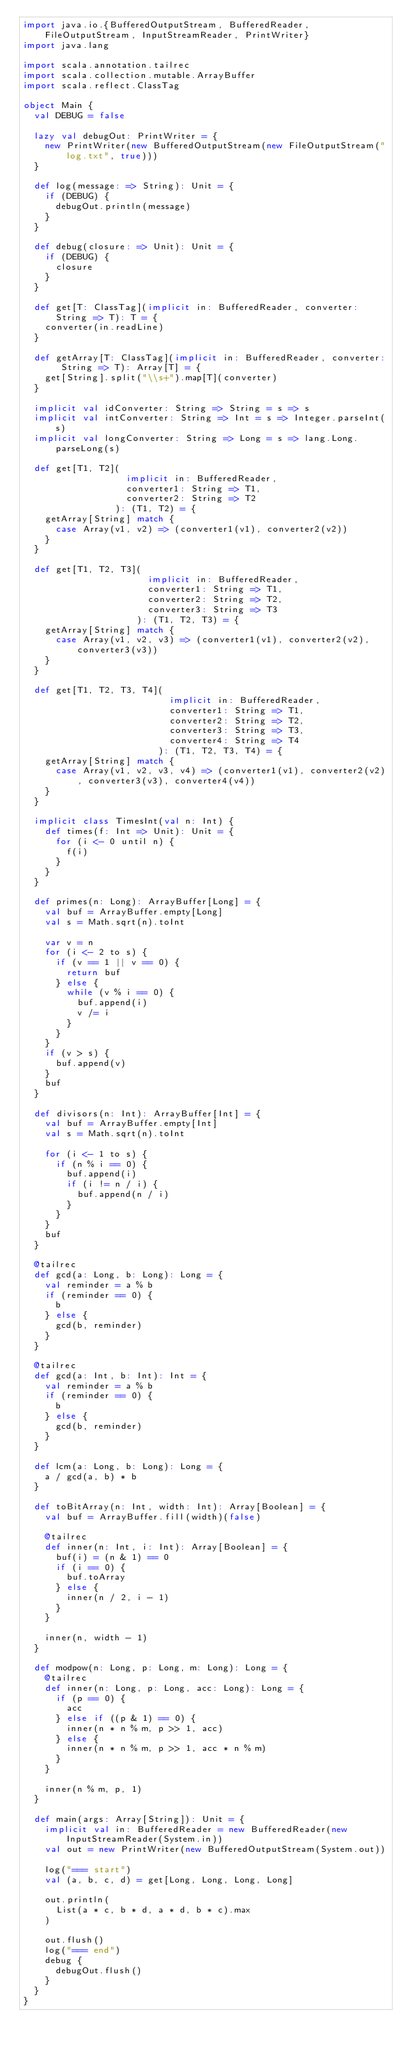Convert code to text. <code><loc_0><loc_0><loc_500><loc_500><_Scala_>import java.io.{BufferedOutputStream, BufferedReader, FileOutputStream, InputStreamReader, PrintWriter}
import java.lang

import scala.annotation.tailrec
import scala.collection.mutable.ArrayBuffer
import scala.reflect.ClassTag

object Main {
  val DEBUG = false

  lazy val debugOut: PrintWriter = {
    new PrintWriter(new BufferedOutputStream(new FileOutputStream("log.txt", true)))
  }

  def log(message: => String): Unit = {
    if (DEBUG) {
      debugOut.println(message)
    }
  }

  def debug(closure: => Unit): Unit = {
    if (DEBUG) {
      closure
    }
  }

  def get[T: ClassTag](implicit in: BufferedReader, converter: String => T): T = {
    converter(in.readLine)
  }

  def getArray[T: ClassTag](implicit in: BufferedReader, converter: String => T): Array[T] = {
    get[String].split("\\s+").map[T](converter)
  }

  implicit val idConverter: String => String = s => s
  implicit val intConverter: String => Int = s => Integer.parseInt(s)
  implicit val longConverter: String => Long = s => lang.Long.parseLong(s)

  def get[T1, T2](
                   implicit in: BufferedReader,
                   converter1: String => T1,
                   converter2: String => T2
                 ): (T1, T2) = {
    getArray[String] match {
      case Array(v1, v2) => (converter1(v1), converter2(v2))
    }
  }

  def get[T1, T2, T3](
                       implicit in: BufferedReader,
                       converter1: String => T1,
                       converter2: String => T2,
                       converter3: String => T3
                     ): (T1, T2, T3) = {
    getArray[String] match {
      case Array(v1, v2, v3) => (converter1(v1), converter2(v2), converter3(v3))
    }
  }

  def get[T1, T2, T3, T4](
                           implicit in: BufferedReader,
                           converter1: String => T1,
                           converter2: String => T2,
                           converter3: String => T3,
                           converter4: String => T4
                         ): (T1, T2, T3, T4) = {
    getArray[String] match {
      case Array(v1, v2, v3, v4) => (converter1(v1), converter2(v2), converter3(v3), converter4(v4))
    }
  }

  implicit class TimesInt(val n: Int) {
    def times(f: Int => Unit): Unit = {
      for (i <- 0 until n) {
        f(i)
      }
    }
  }

  def primes(n: Long): ArrayBuffer[Long] = {
    val buf = ArrayBuffer.empty[Long]
    val s = Math.sqrt(n).toInt

    var v = n
    for (i <- 2 to s) {
      if (v == 1 || v == 0) {
        return buf
      } else {
        while (v % i == 0) {
          buf.append(i)
          v /= i
        }
      }
    }
    if (v > s) {
      buf.append(v)
    }
    buf
  }

  def divisors(n: Int): ArrayBuffer[Int] = {
    val buf = ArrayBuffer.empty[Int]
    val s = Math.sqrt(n).toInt

    for (i <- 1 to s) {
      if (n % i == 0) {
        buf.append(i)
        if (i != n / i) {
          buf.append(n / i)
        }
      }
    }
    buf
  }

  @tailrec
  def gcd(a: Long, b: Long): Long = {
    val reminder = a % b
    if (reminder == 0) {
      b
    } else {
      gcd(b, reminder)
    }
  }

  @tailrec
  def gcd(a: Int, b: Int): Int = {
    val reminder = a % b
    if (reminder == 0) {
      b
    } else {
      gcd(b, reminder)
    }
  }

  def lcm(a: Long, b: Long): Long = {
    a / gcd(a, b) * b
  }

  def toBitArray(n: Int, width: Int): Array[Boolean] = {
    val buf = ArrayBuffer.fill(width)(false)

    @tailrec
    def inner(n: Int, i: Int): Array[Boolean] = {
      buf(i) = (n & 1) == 0
      if (i == 0) {
        buf.toArray
      } else {
        inner(n / 2, i - 1)
      }
    }

    inner(n, width - 1)
  }

  def modpow(n: Long, p: Long, m: Long): Long = {
    @tailrec
    def inner(n: Long, p: Long, acc: Long): Long = {
      if (p == 0) {
        acc
      } else if ((p & 1) == 0) {
        inner(n * n % m, p >> 1, acc)
      } else {
        inner(n * n % m, p >> 1, acc * n % m)
      }
    }

    inner(n % m, p, 1)
  }

  def main(args: Array[String]): Unit = {
    implicit val in: BufferedReader = new BufferedReader(new InputStreamReader(System.in))
    val out = new PrintWriter(new BufferedOutputStream(System.out))

    log("=== start")
    val (a, b, c, d) = get[Long, Long, Long, Long]

    out.println(
      List(a * c, b * d, a * d, b * c).max
    )

    out.flush()
    log("=== end")
    debug {
      debugOut.flush()
    }
  }
}</code> 